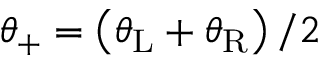<formula> <loc_0><loc_0><loc_500><loc_500>\theta _ { + } = \left ( \theta _ { L } + \theta _ { R } \right ) / 2</formula> 